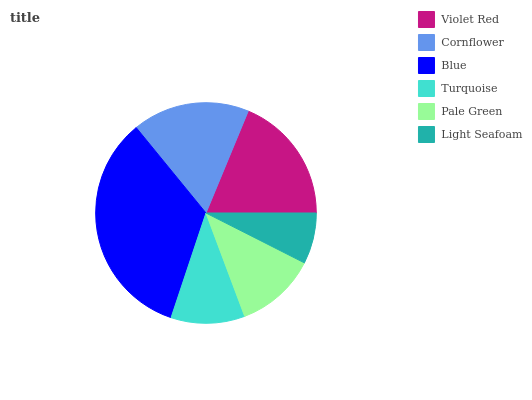Is Light Seafoam the minimum?
Answer yes or no. Yes. Is Blue the maximum?
Answer yes or no. Yes. Is Cornflower the minimum?
Answer yes or no. No. Is Cornflower the maximum?
Answer yes or no. No. Is Violet Red greater than Cornflower?
Answer yes or no. Yes. Is Cornflower less than Violet Red?
Answer yes or no. Yes. Is Cornflower greater than Violet Red?
Answer yes or no. No. Is Violet Red less than Cornflower?
Answer yes or no. No. Is Cornflower the high median?
Answer yes or no. Yes. Is Pale Green the low median?
Answer yes or no. Yes. Is Blue the high median?
Answer yes or no. No. Is Cornflower the low median?
Answer yes or no. No. 